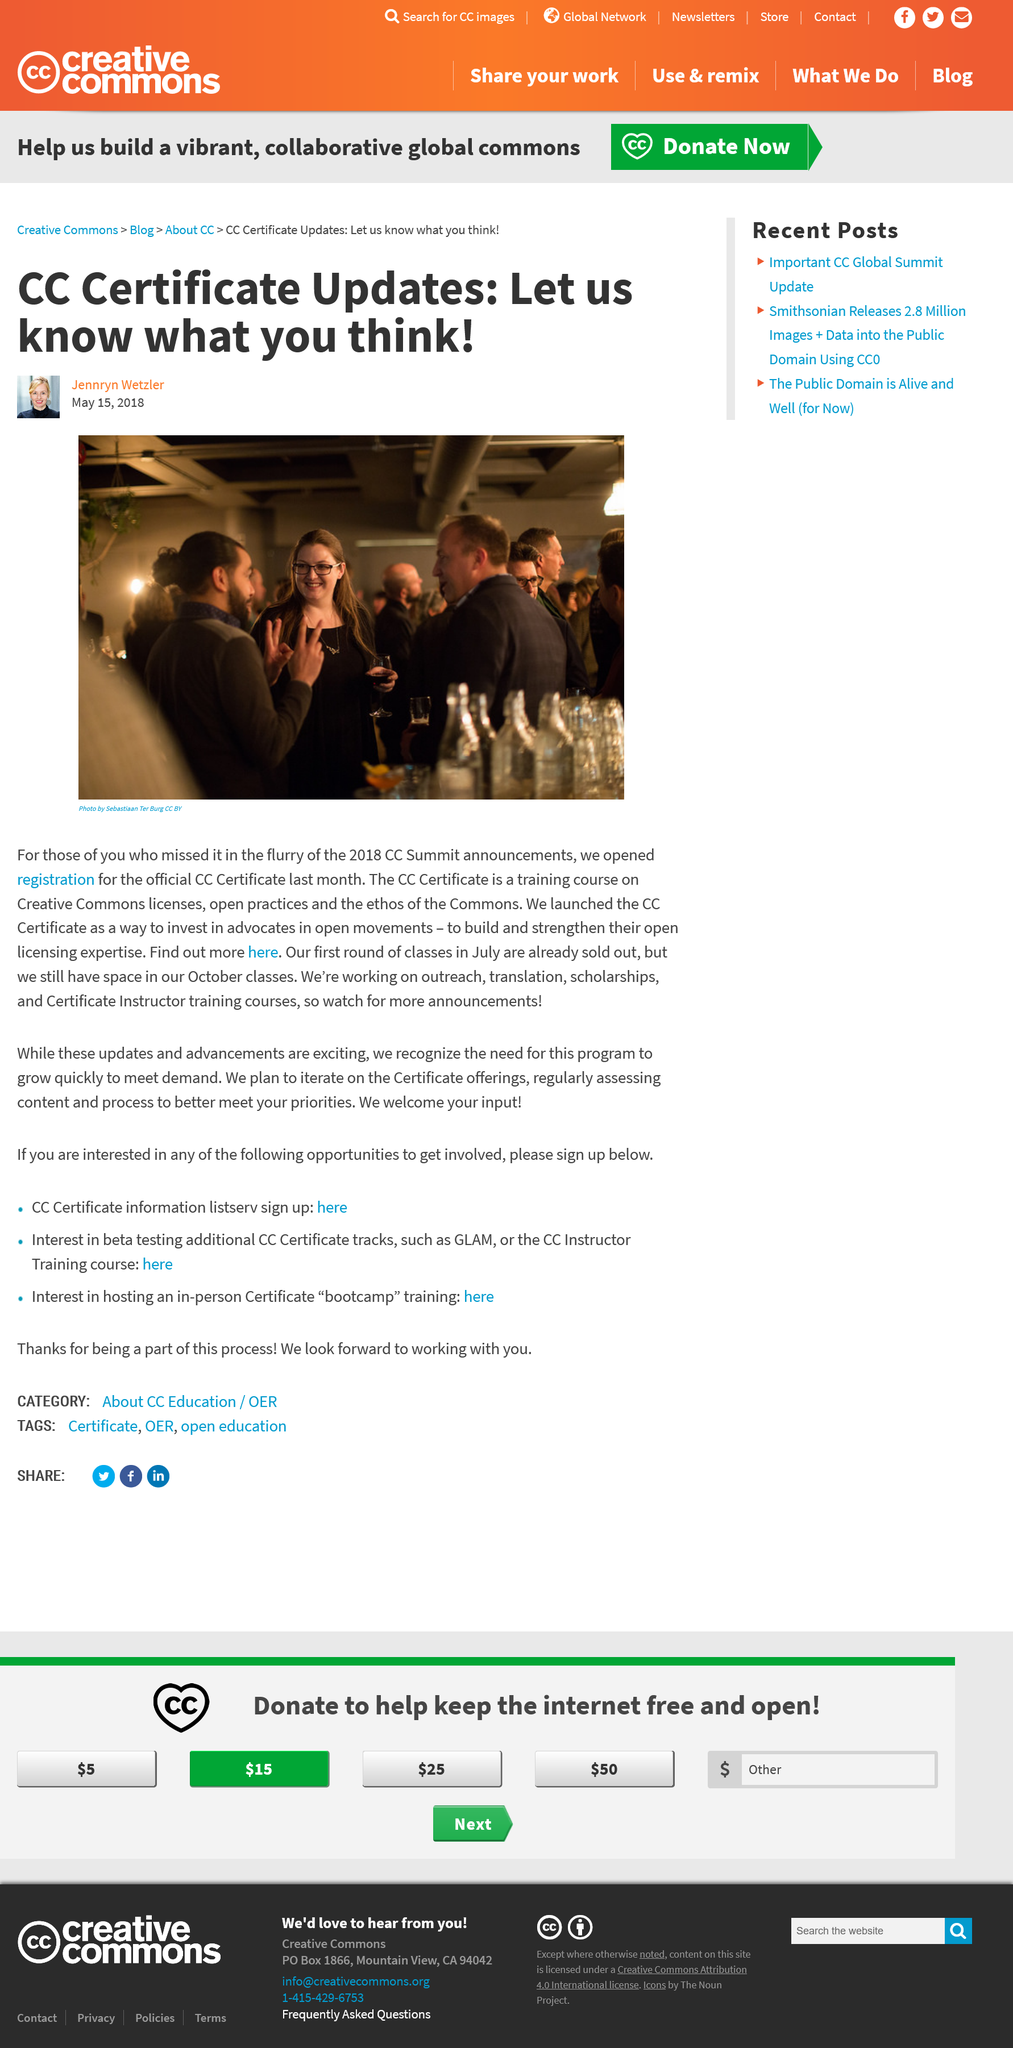List a handful of essential elements in this visual. This article was published on May 15, 2018. The CC Certificate is a training course on Creative Commons licenses, open practices, and the ethos of the Commons. The CC Certificate was launched to support and invest in advocates participating in open movements. 